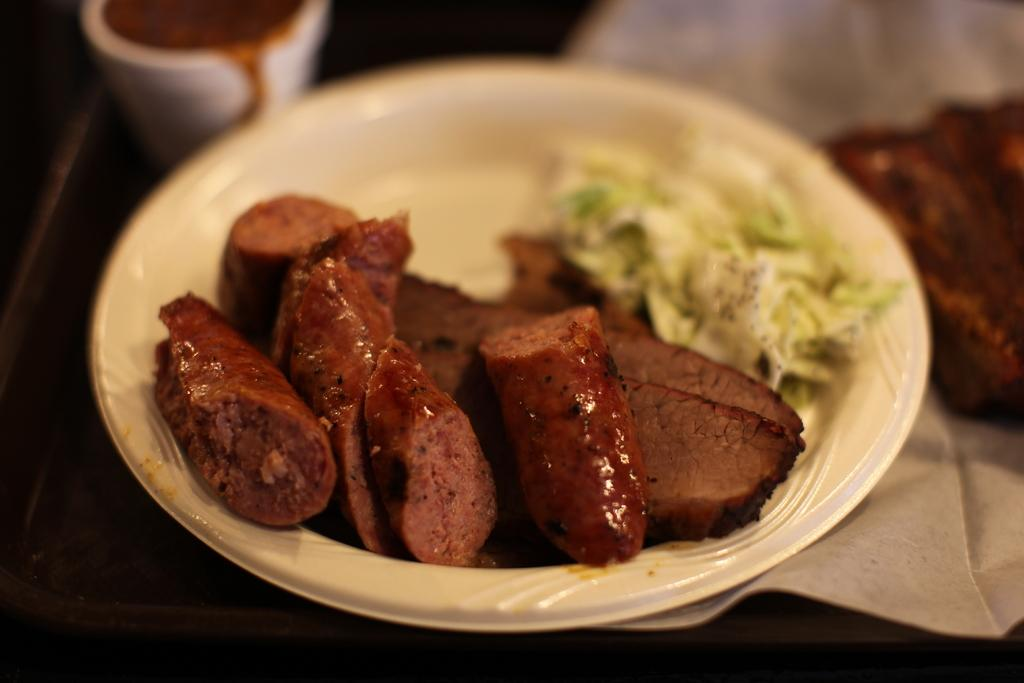What is present on the plate in the image? There is food on the plate in the image. What else can be seen on the table besides the plate? There is a cup in the image. Is there anything else visible on the table? Yes, there is a tissue paper on the right side of the image. How would you describe the background of the image? The background of the image is blurry. How many jellyfish are swimming in the cup in the image? There are no jellyfish present in the image; it features a cup and a plate with food. What type of nerve is visible in the tissue paper on the right side of the image? There is no nerve visible in the tissue paper or any other part of the image. 